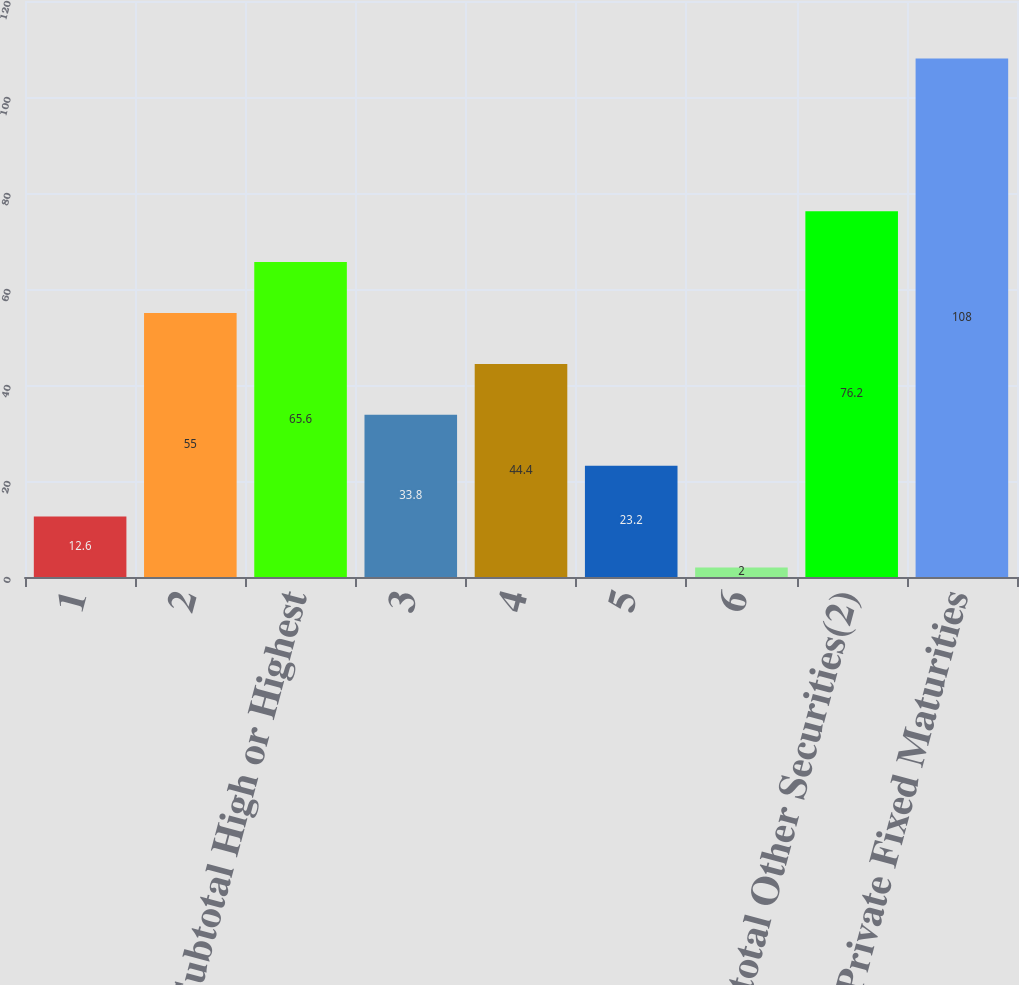<chart> <loc_0><loc_0><loc_500><loc_500><bar_chart><fcel>1<fcel>2<fcel>Subtotal High or Highest<fcel>3<fcel>4<fcel>5<fcel>6<fcel>Subtotal Other Securities(2)<fcel>Total Private Fixed Maturities<nl><fcel>12.6<fcel>55<fcel>65.6<fcel>33.8<fcel>44.4<fcel>23.2<fcel>2<fcel>76.2<fcel>108<nl></chart> 